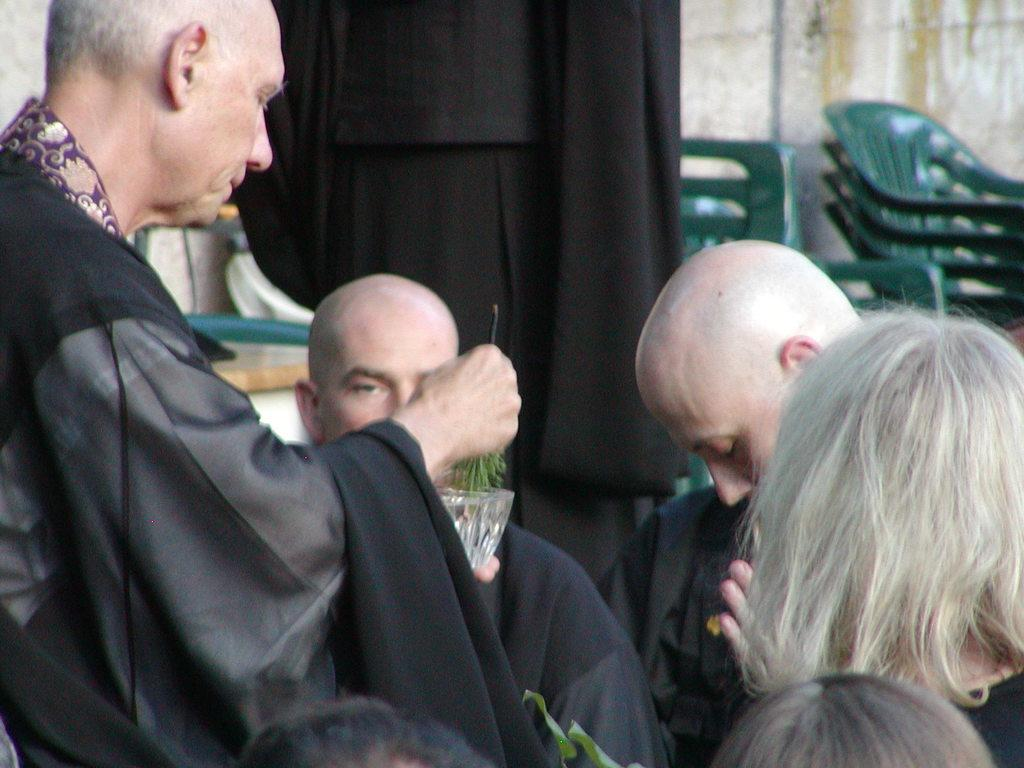Who or what is present in the image? There are people in the image. What are the people wearing? The people are wearing black color dress. What can be seen in the background of the image? There are chairs and a wall in the background of the image. Is there a key floating in the river in the image? There is no river or key present in the image. 